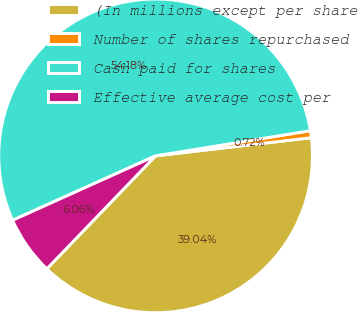Convert chart. <chart><loc_0><loc_0><loc_500><loc_500><pie_chart><fcel>(In millions except per share<fcel>Number of shares repurchased<fcel>Cash paid for shares<fcel>Effective average cost per<nl><fcel>39.04%<fcel>0.72%<fcel>54.17%<fcel>6.06%<nl></chart> 